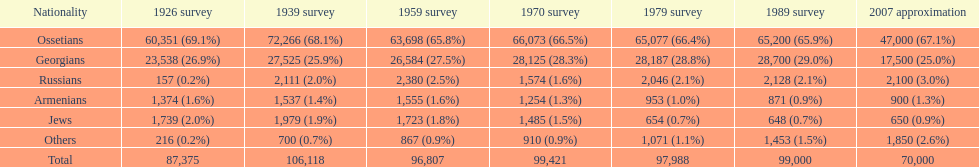Which ethnicity is at the pinnacle? Ossetians. 